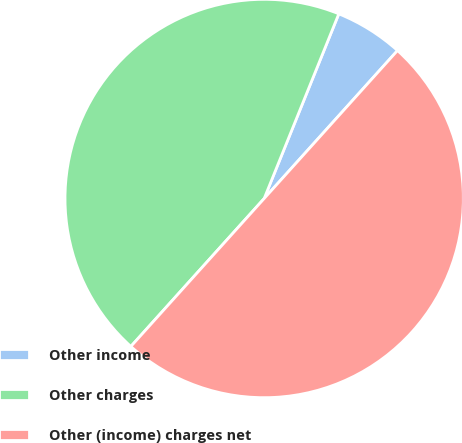<chart> <loc_0><loc_0><loc_500><loc_500><pie_chart><fcel>Other income<fcel>Other charges<fcel>Other (income) charges net<nl><fcel>5.56%<fcel>44.44%<fcel>50.0%<nl></chart> 